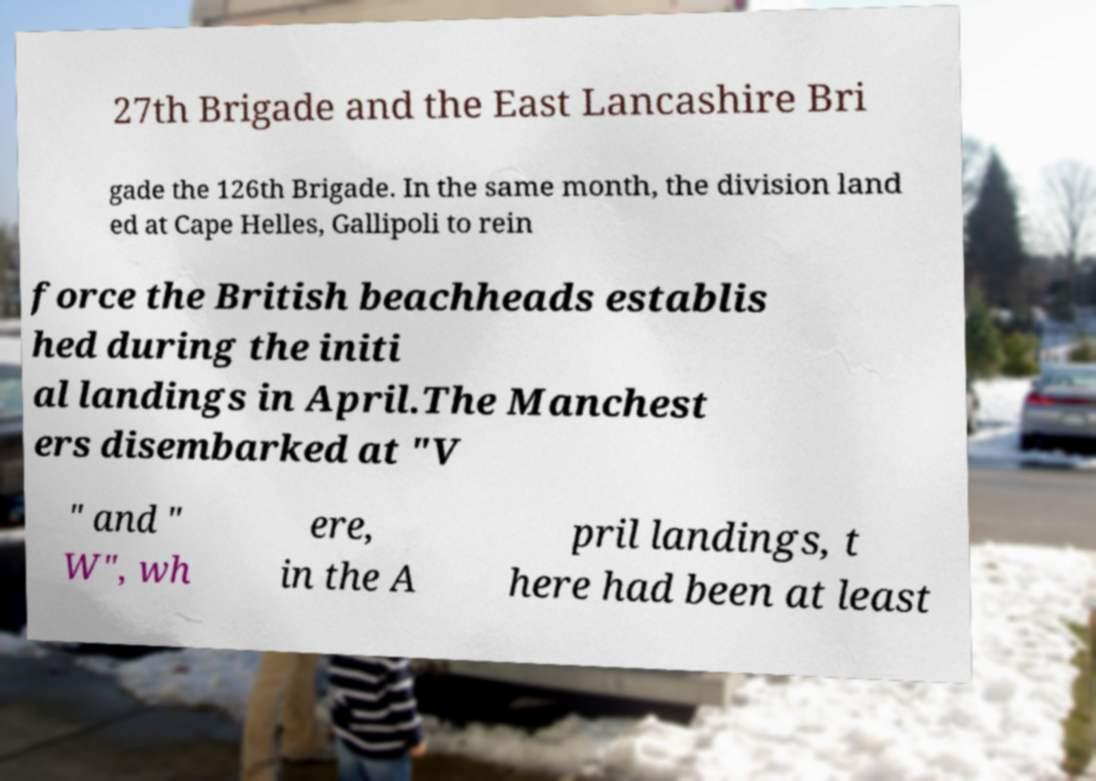I need the written content from this picture converted into text. Can you do that? 27th Brigade and the East Lancashire Bri gade the 126th Brigade. In the same month, the division land ed at Cape Helles, Gallipoli to rein force the British beachheads establis hed during the initi al landings in April.The Manchest ers disembarked at "V " and " W", wh ere, in the A pril landings, t here had been at least 